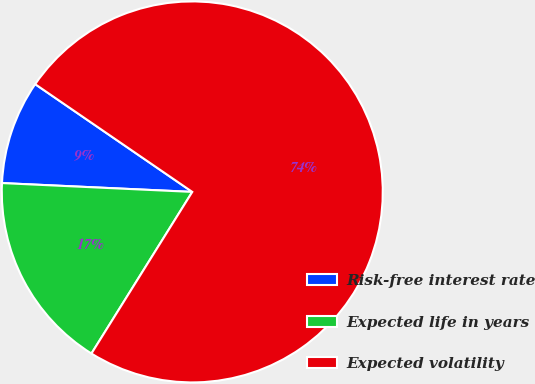Convert chart to OTSL. <chart><loc_0><loc_0><loc_500><loc_500><pie_chart><fcel>Risk-free interest rate<fcel>Expected life in years<fcel>Expected volatility<nl><fcel>8.83%<fcel>16.86%<fcel>74.31%<nl></chart> 